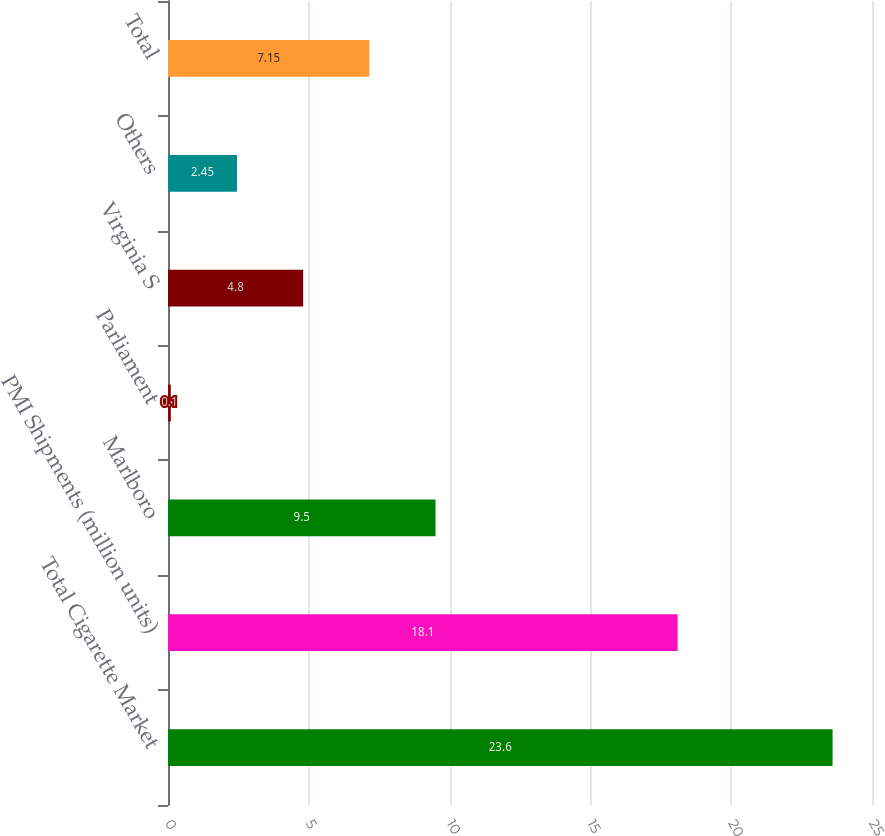Convert chart to OTSL. <chart><loc_0><loc_0><loc_500><loc_500><bar_chart><fcel>Total Cigarette Market<fcel>PMI Shipments (million units)<fcel>Marlboro<fcel>Parliament<fcel>Virginia S<fcel>Others<fcel>Total<nl><fcel>23.6<fcel>18.1<fcel>9.5<fcel>0.1<fcel>4.8<fcel>2.45<fcel>7.15<nl></chart> 